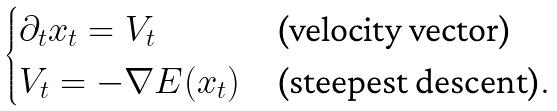Convert formula to latex. <formula><loc_0><loc_0><loc_500><loc_500>\begin{cases} \partial _ { t } x _ { t } = V _ { t } & \text {(velocity vector)} \\ V _ { t } = - \nabla E ( x _ { t } ) & \text {(steepest descent)} . \end{cases}</formula> 